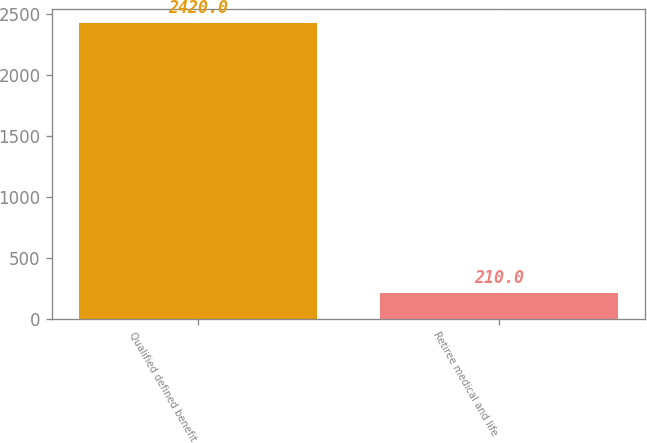<chart> <loc_0><loc_0><loc_500><loc_500><bar_chart><fcel>Qualified defined benefit<fcel>Retiree medical and life<nl><fcel>2420<fcel>210<nl></chart> 